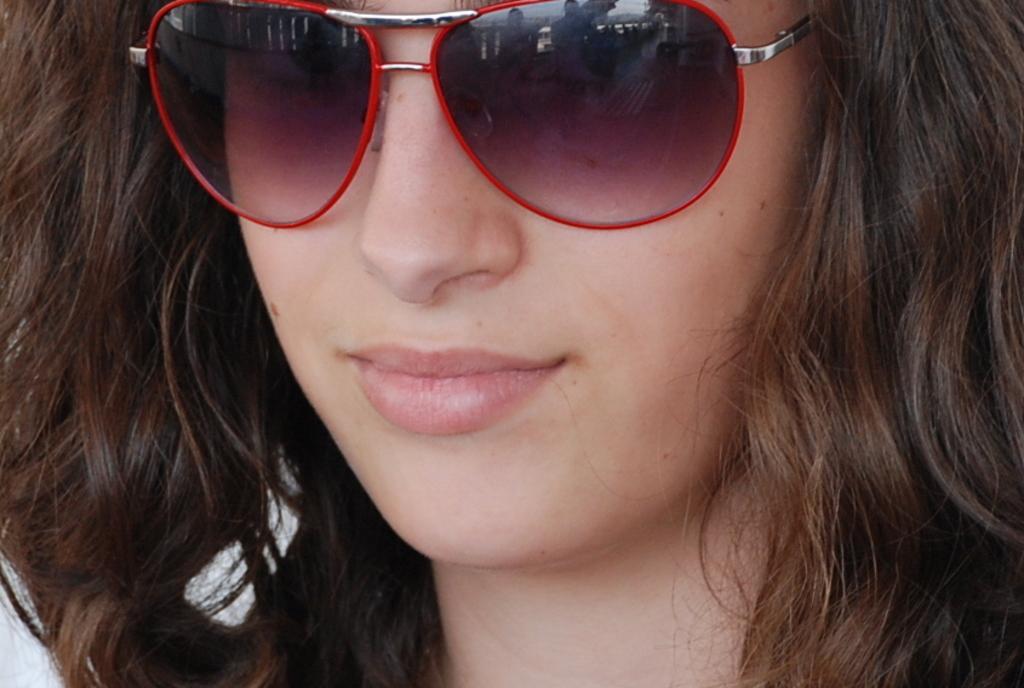Can you describe this image briefly? In this image we can see a lady wearing goggles. 